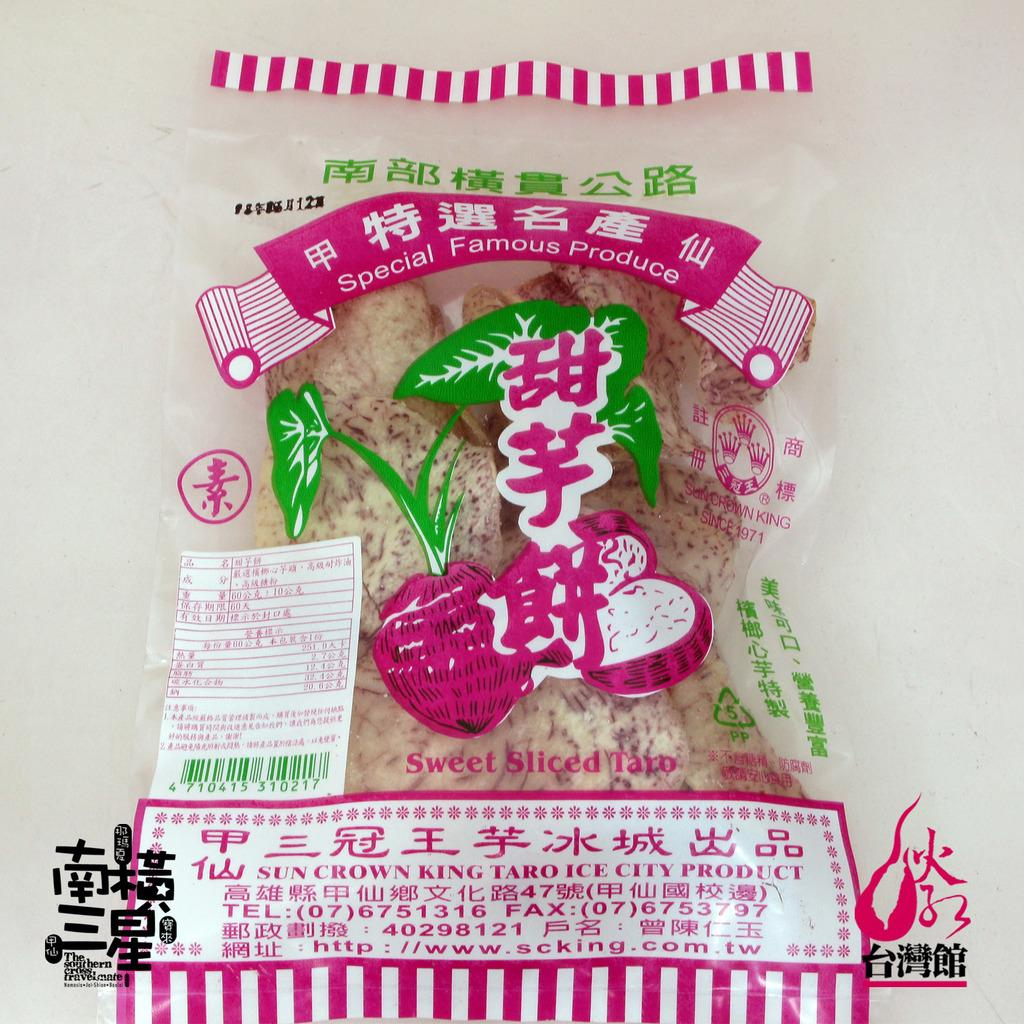<image>
Write a terse but informative summary of the picture. A bag of Sweet sliced taro in a clear back with pink writing. 